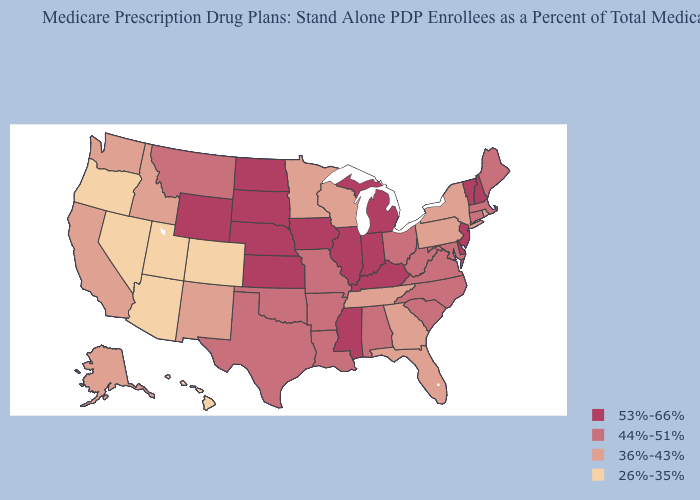Does the first symbol in the legend represent the smallest category?
Quick response, please. No. Does Arkansas have a higher value than Alaska?
Short answer required. Yes. What is the highest value in the MidWest ?
Concise answer only. 53%-66%. Name the states that have a value in the range 26%-35%?
Keep it brief. Arizona, Colorado, Hawaii, Nevada, Oregon, Utah. Name the states that have a value in the range 26%-35%?
Give a very brief answer. Arizona, Colorado, Hawaii, Nevada, Oregon, Utah. Among the states that border North Dakota , which have the highest value?
Answer briefly. South Dakota. How many symbols are there in the legend?
Write a very short answer. 4. What is the value of Oklahoma?
Answer briefly. 44%-51%. Name the states that have a value in the range 36%-43%?
Write a very short answer. Alaska, California, Florida, Georgia, Idaho, Minnesota, New Mexico, New York, Pennsylvania, Rhode Island, Tennessee, Washington, Wisconsin. What is the lowest value in the MidWest?
Keep it brief. 36%-43%. How many symbols are there in the legend?
Keep it brief. 4. How many symbols are there in the legend?
Concise answer only. 4. Does Wyoming have the same value as Kansas?
Be succinct. Yes. Among the states that border Missouri , which have the highest value?
Concise answer only. Iowa, Illinois, Kansas, Kentucky, Nebraska. Does New Jersey have the highest value in the USA?
Short answer required. Yes. 